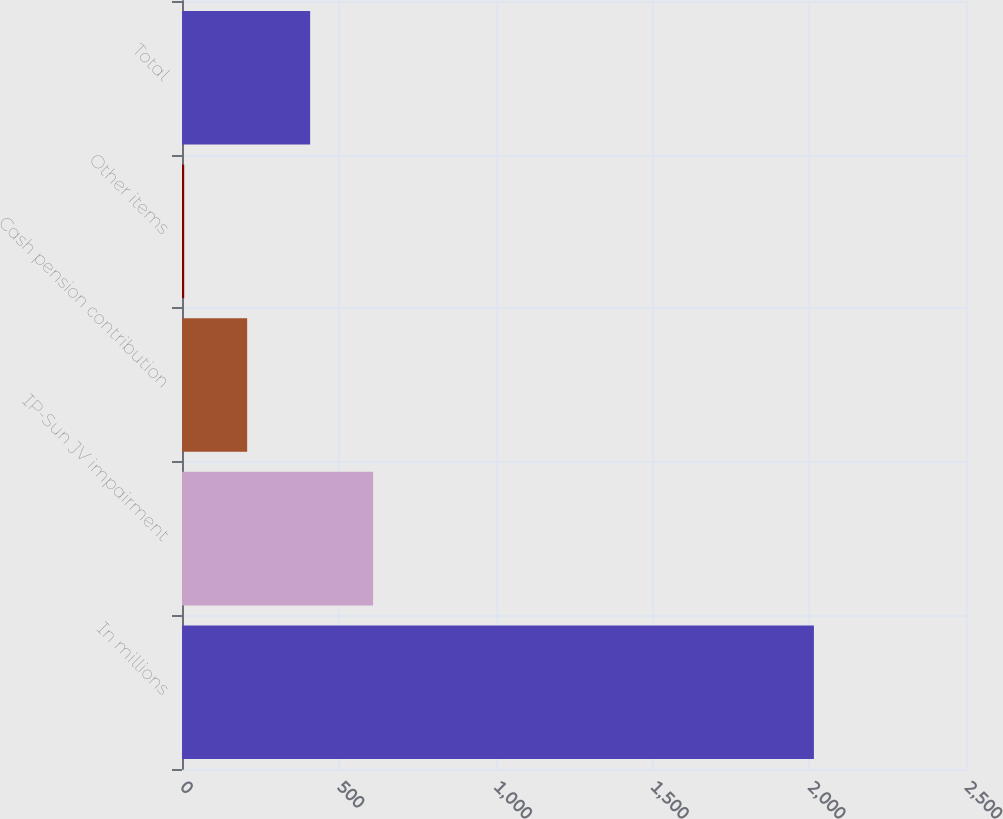Convert chart to OTSL. <chart><loc_0><loc_0><loc_500><loc_500><bar_chart><fcel>In millions<fcel>IP-Sun JV impairment<fcel>Cash pension contribution<fcel>Other items<fcel>Total<nl><fcel>2015<fcel>609.4<fcel>207.8<fcel>7<fcel>408.6<nl></chart> 